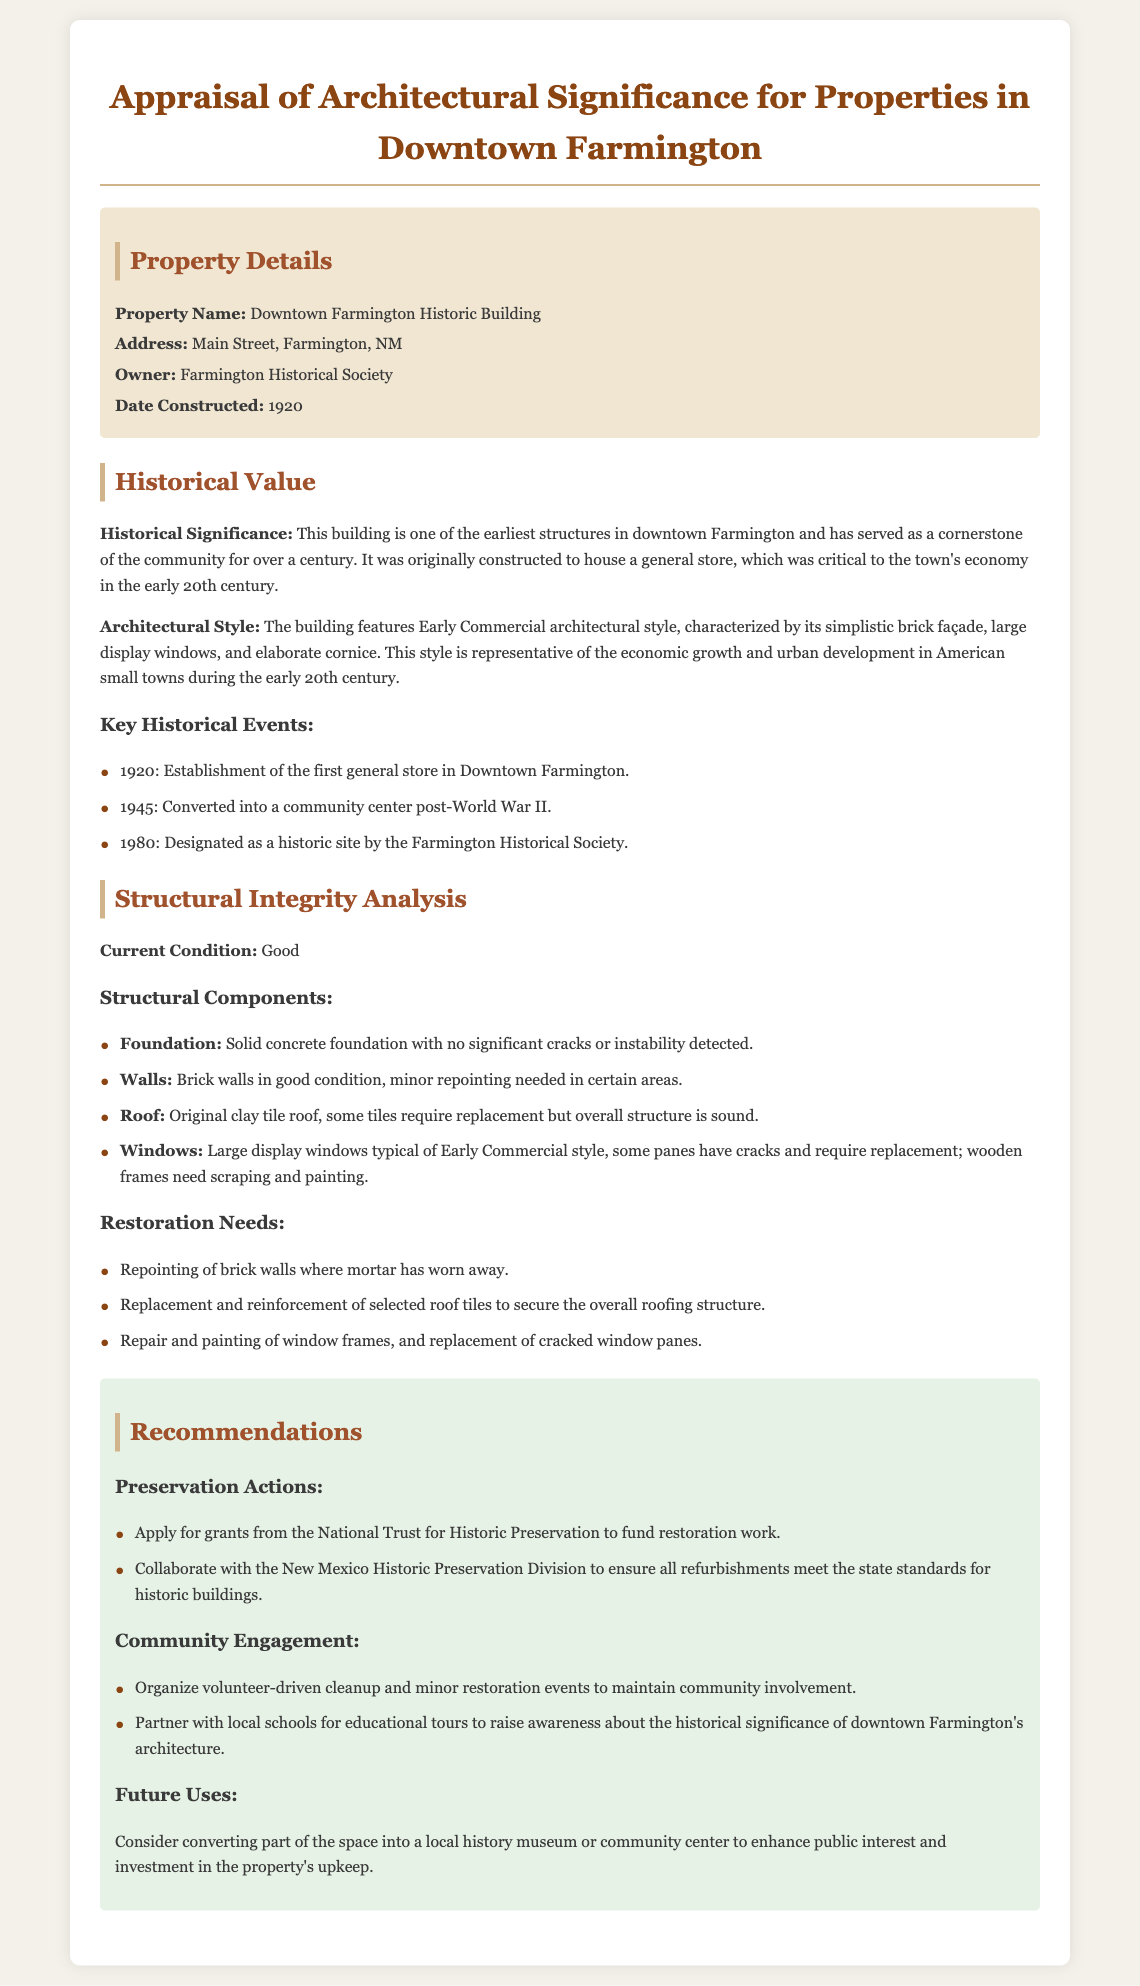what is the property name? The property name is specified under the Property Details section in the document.
Answer: Downtown Farmington Historic Building who is the owner of the property? The owner's name is listed under the Property Details section.
Answer: Farmington Historical Society in what year was the building constructed? The date of construction is provided in the Property Details section.
Answer: 1920 what architectural style is the building? The architectural style is mentioned in the Historical Value section of the document.
Answer: Early Commercial how many key historical events are listed? The number of events can be counted under the Key Historical Events subsection in the Historical Value section.
Answer: 3 what is the current condition of the building? The current condition is stated in the Structural Integrity Analysis section.
Answer: Good which restoration need involves the roof? The restoration needs are outlined in the Structural Integrity Analysis section, needing specific attention to the roof.
Answer: Replacement and reinforcement of selected roof tiles what is one recommended preservation action? Recommendations are listed and the preservation actions are specifically outlined in the Recommendations section.
Answer: Apply for grants from the National Trust for Historic Preservation what is a suggested future use for the property? Future uses for the property are described towards the end of the document in the Recommendations section.
Answer: Local history museum or community center 